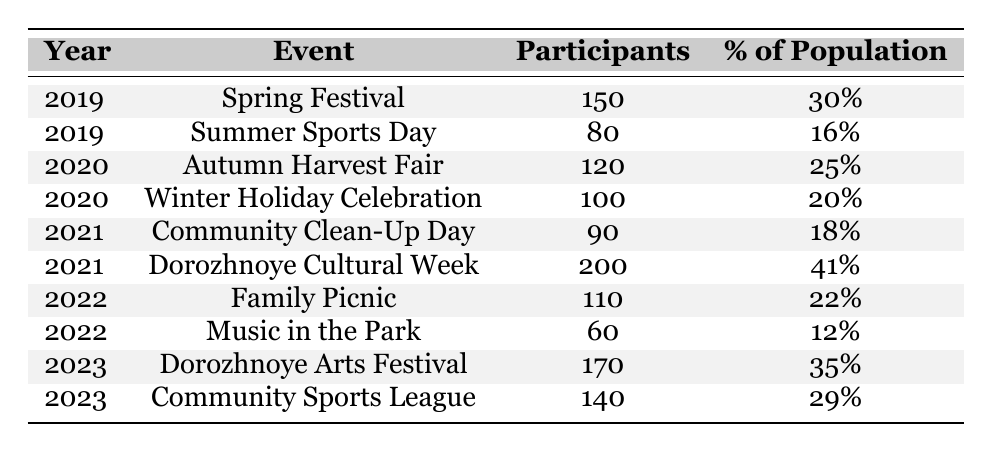What event had the highest participant count in 2021? According to the table, in 2021, the event with the highest participant count was the "Dorozhnoye Cultural Week," with 200 participants, while the "Community Clean-Up Day" had only 90 participants.
Answer: Dorozhnoye Cultural Week What year had the lowest percentage of population participating in a community event? Looking at the table, the lowest percentage of population participating in a community event occurred in 2022 during the "Music in the Park" event, which had only 12%.
Answer: 2022 How many participants were there in total across all events in 2023? To find the total participants for 2023, we take the summation of participants from both events: 170 (Dorozhnoye Arts Festival) + 140 (Community Sports League) = 310 participants.
Answer: 310 Which event in 2019 had a higher percentage of the population participating: Spring Festival or Summer Sports Day? The "Spring Festival" in 2019 had 30% participation, while "Summer Sports Day" had only 16%. Therefore, the Spring Festival had a higher percentage of the population participating.
Answer: Spring Festival Calculate the average percentage of the population participating across all events in 2020. For 2020, we have two events: "Autumn Harvest Fair" with 25% and "Winter Holiday Celebration" with 20%. The average is calculated as (25 + 20)/2 = 22.5%.
Answer: 22.5% Did more than 100 participants attend any event in 2022? In 2022, there were two events: "Family Picnic" with 110 participants and "Music in the Park" with 60 participants. Since 110 is greater than 100, there was indeed an event with more than 100 participants that year.
Answer: Yes What is the percentage increase in participation from the Community Clean-Up Day in 2021 to the Dorozhnoye Arts Festival in 2023? The Community Clean-Up Day had 90 participants in 2021 and the Dorozhnoye Arts Festival had 170 participants in 2023. The increase is (170 - 90) = 80 participants. To find the percentage increase, we use (80 / 90) * 100, which equals approximately 88.89%.
Answer: 88.89% In which year did the highest number of total participants across all events occur? To determine the year with the highest total participants, we sum the participants for each year: 2019 (150 + 80 = 230), 2020 (120 + 100 = 220), 2021 (90 + 200 = 290), 2022 (110 + 60 = 170), and 2023 (170 + 140 = 310). The highest total occurred in 2023 with 310 participants.
Answer: 2023 